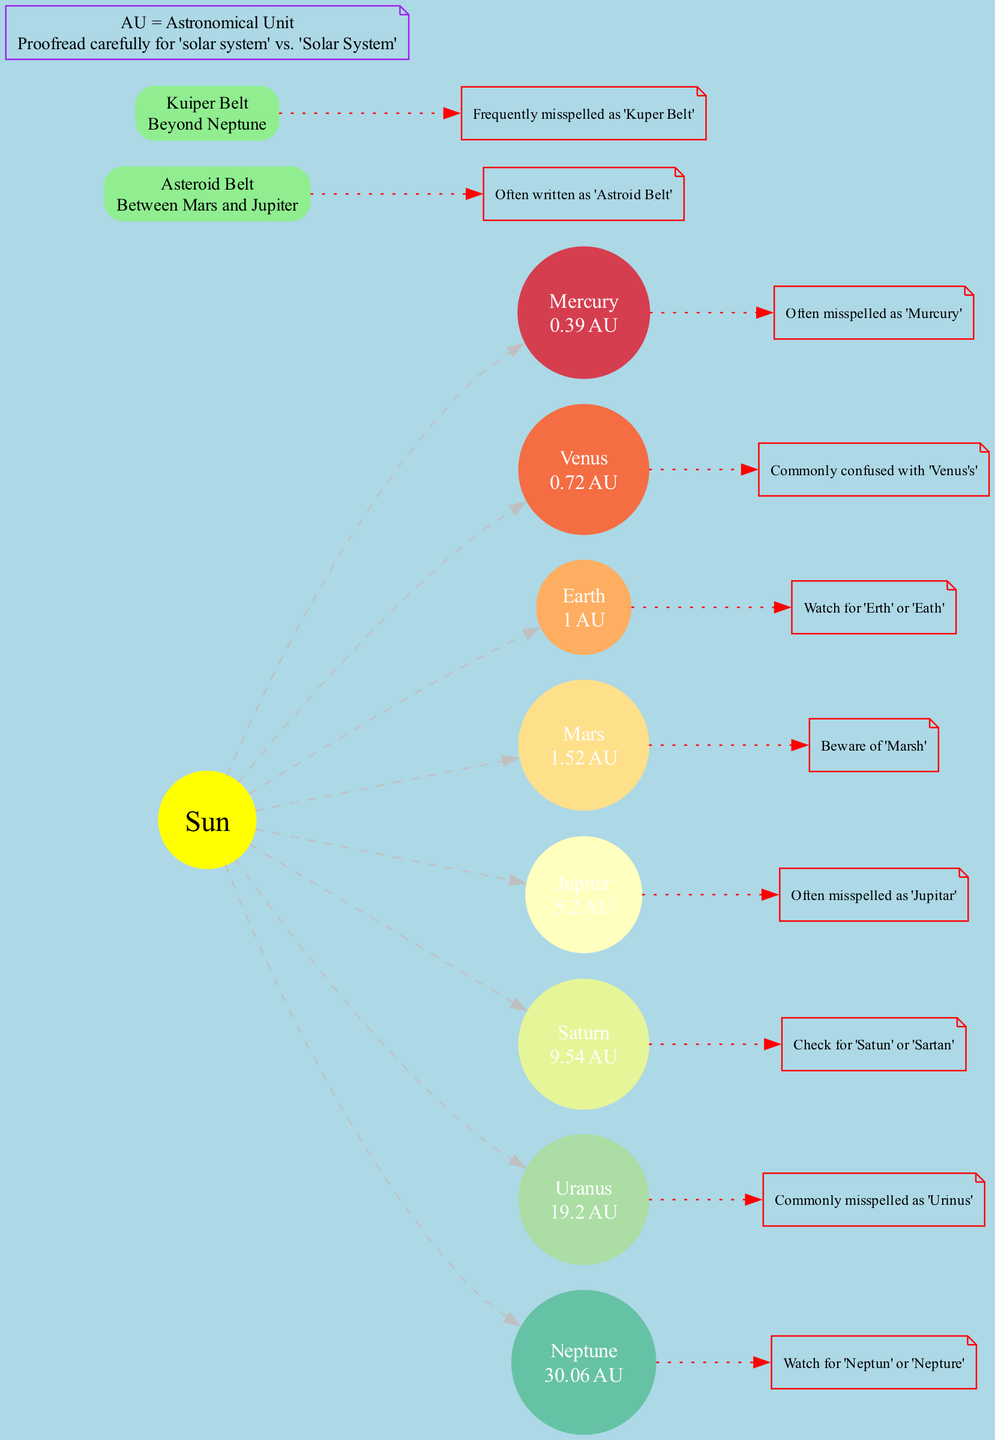What is the distance of Mars from the Sun? The diagram indicates that Mars is located at a distance of 1.52 AU from the Sun, directly stated in the distance annotation next to Mars.
Answer: 1.52 AU What common spelling error is associated with Uranus? According to the annotation for Uranus in the diagram, it is often misspelled as 'Urinus'. This information is provided as a specific note next to the planet's label.
Answer: Urinus How many planets are listed in the diagram? By counting the entries in the planets section of the diagram, there are a total of eight planets mentioned: Mercury, Venus, Earth, Mars, Jupiter, Saturn, Uranus, and Neptune.
Answer: 8 What is the annotation for the Asteroid Belt? The diagram specifically notes that the Asteroid Belt is often written as 'Astroid Belt', which is an important spelling error highlighted in the annotation for this element.
Answer: Astroid Belt Which planet is mistakenly written as 'Jupitar'? The annotation for Jupiter in the diagram highlights that it is often misspelled as 'Jupitar'. To find this, one must look under the Jupiter section in the diagram.
Answer: Jupitar What is the location of the Kuiper Belt? The Kuiper Belt is indicated in the diagram as being located beyond Neptune. This information is presented alongside its name in the other elements section.
Answer: Beyond Neptune What planet is associated with the annotation 'Beware of Marsh'? The diagram annotations specify that the spelling error 'Marsh' is associated with the planet Mars. This is explicitly mentioned next to Mars in the diagram.
Answer: Mars How far is Neptune from the Sun? The distance indicated in the diagram for Neptune is 30.06 AU, as stated in the distance annotation next to Neptune's label.
Answer: 30.06 AU Which astronomical unit does the diagram refer to as AU? The additional notes section of the diagram defines AU as Astronomical Unit, clarifying what the abbreviation stands for in the context of the solar system distances shown.
Answer: Astronomical Unit 